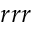<formula> <loc_0><loc_0><loc_500><loc_500>r r r</formula> 